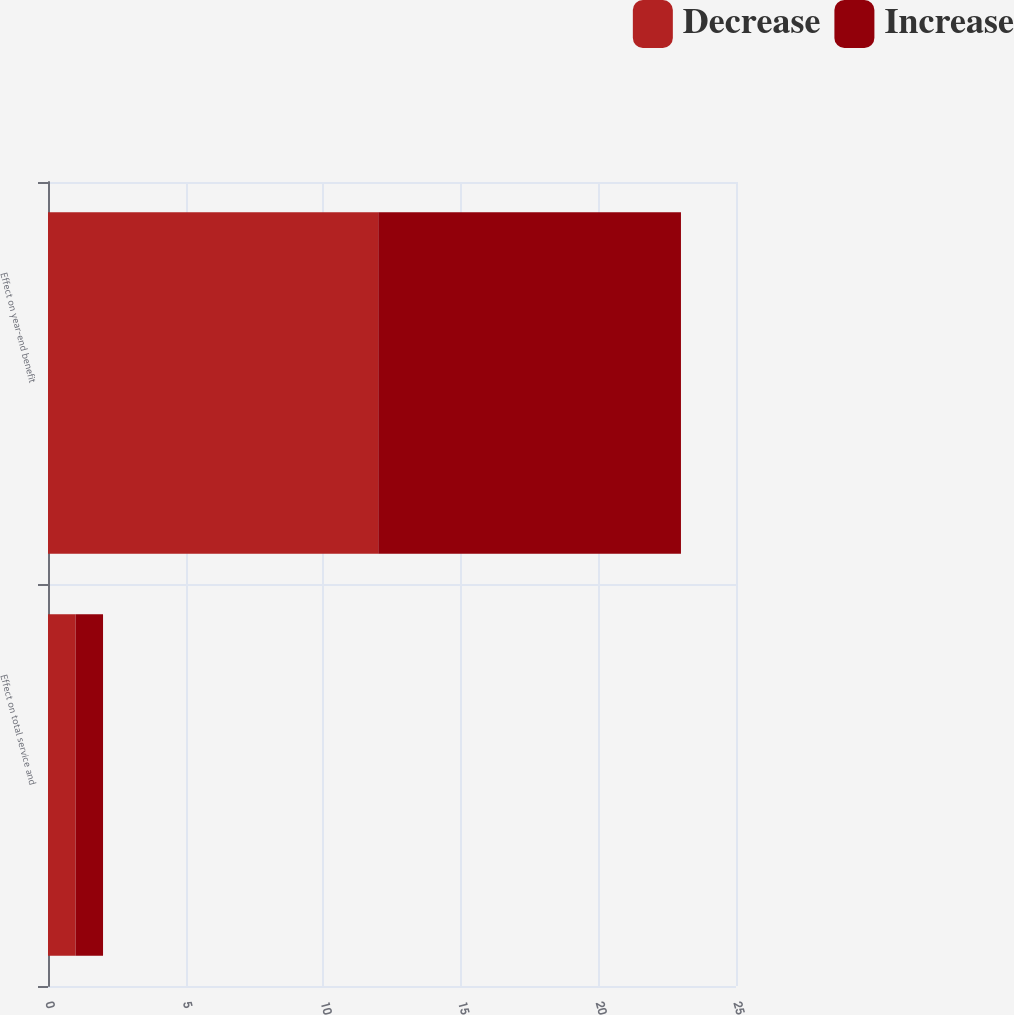Convert chart. <chart><loc_0><loc_0><loc_500><loc_500><stacked_bar_chart><ecel><fcel>Effect on total service and<fcel>Effect on year-end benefit<nl><fcel>Decrease<fcel>1<fcel>12<nl><fcel>Increase<fcel>1<fcel>11<nl></chart> 